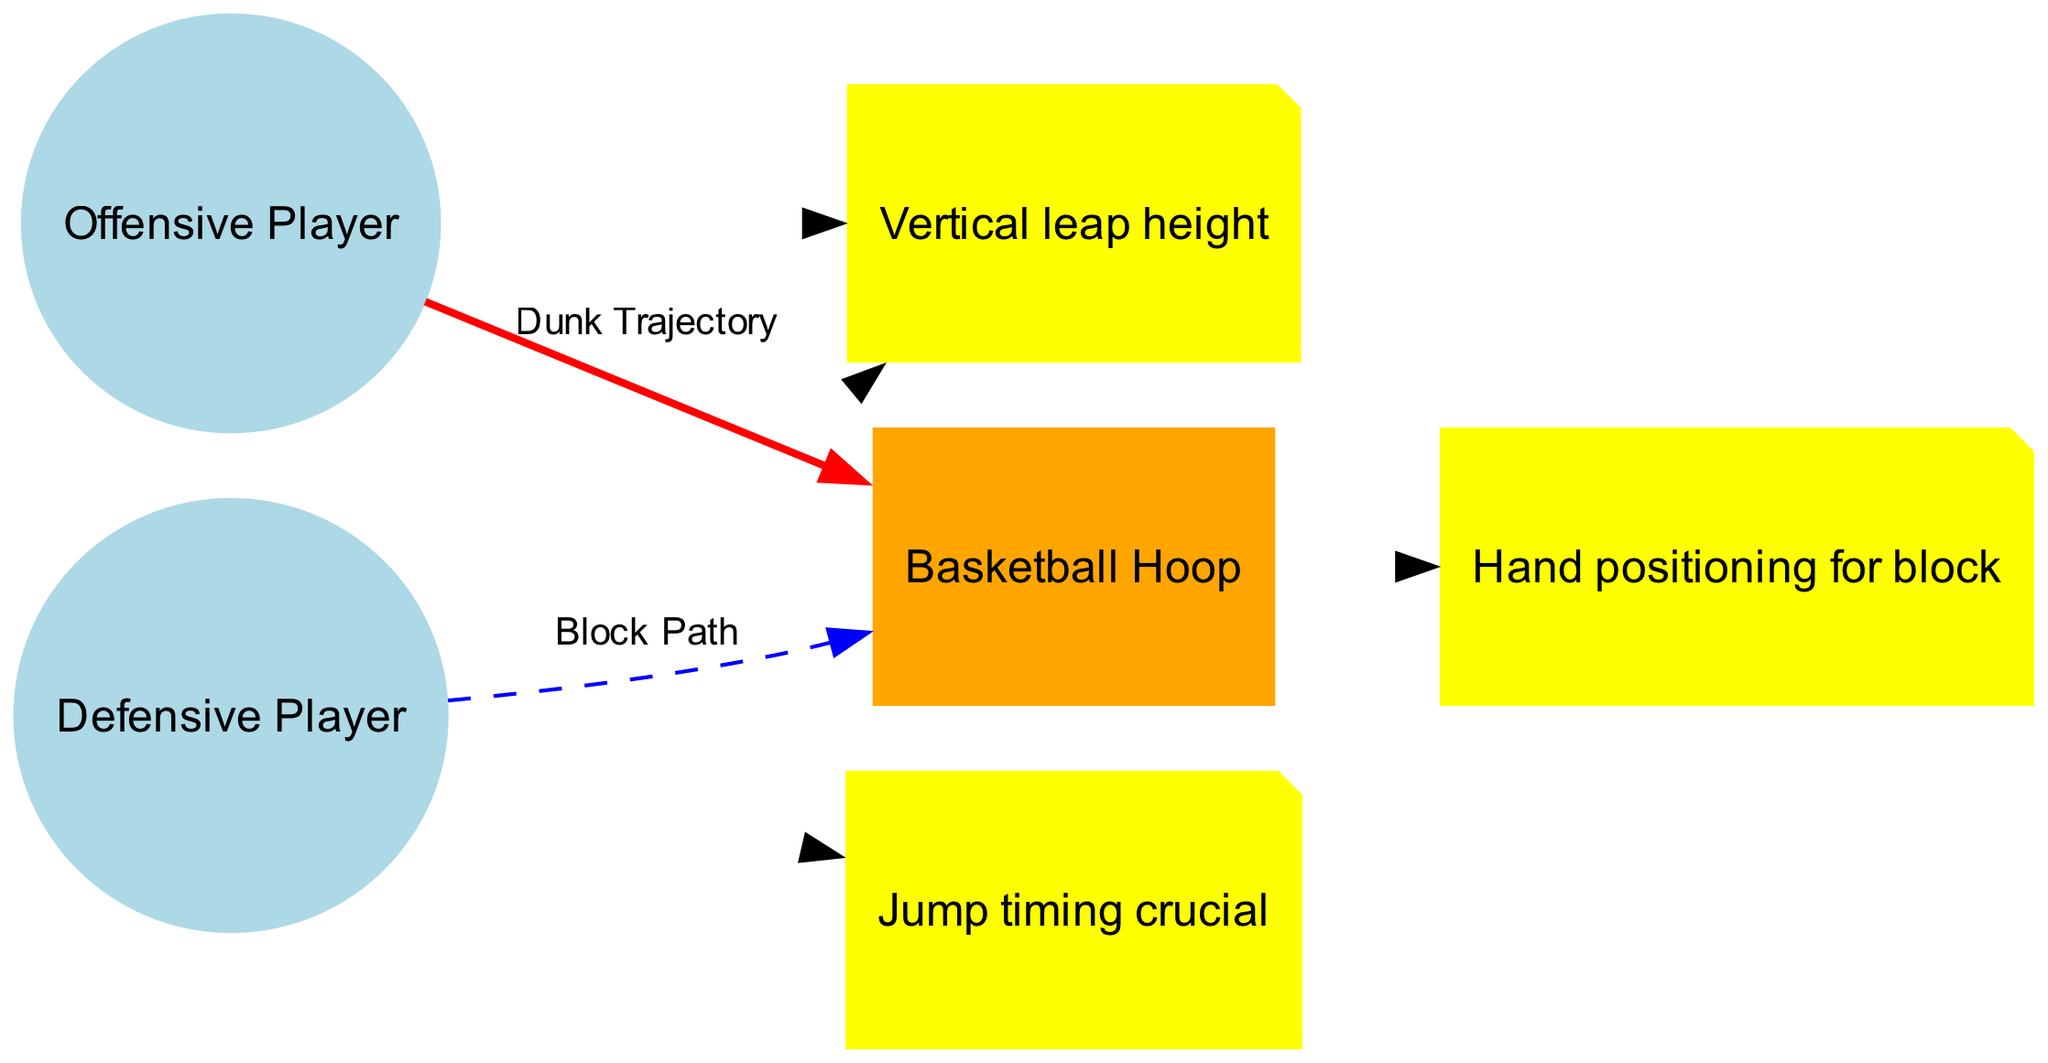What are the types of players represented in the diagram? The diagram includes two types of players: an 'Offensive Player' and a 'Defensive Player'. These are clearly labeled in the respective nodes of the diagram, indicating their roles in the play context.
Answer: Offensive Player and Defensive Player How many edges are in the diagram? The diagram shows two edges: one edge indicates the 'Dunk Trajectory' from the 'Offensive Player' to the 'Basketball Hoop', and the second edge indicates the 'Block Path' from the 'Defensive Player' to the 'Basketball Hoop'. Therefore, the total count of edges is two.
Answer: 2 What does the red edge represent? In the diagram, the red edge represents the 'Dunk Trajectory', which is the path the offensive player takes to attempt a dunk. The coloration emphasizes its significance in the context of the offensive play.
Answer: Dunk Trajectory What is the relationship between the Offensive Player and the Basketball Hoop? The relationship depicted is a 'Dunk Trajectory', which shows that the offensive player is aiming to score by dunking the ball into the basketball hoop, which is represented by a directed edge connecting them in this diagram.
Answer: Dunk Trajectory What annotation is located near the Defensive Player? The annotation that is located near the defensive player states "Jump timing crucial". This highlights an important strategic aspect regarding the timing of the jump to effectively block the dunk.
Answer: Jump timing crucial What is indicated by the annotation positioned between the players? The annotation "Vertical leap height" positioned between the offensive and defensive players signifies that the difference in their vertical leaping abilities is critical to the outcome of the dunk attempt versus the block.
Answer: Vertical leap height What color is the Basketball Hoop in the diagram? The Basketball Hoop is colored orange in the diagram, distinguishing it from the players, who are represented with a light blue color. The orange color visually signifies its importance in the context of the game.
Answer: Orange What does the blue edge signify? The blue edge denotes the 'Block Path', indicating the defensive player's trajectory in attempting to block the dunk shot made by the offensive player. The different color visually differentiates it from the dunk trajectory.
Answer: Block Path 